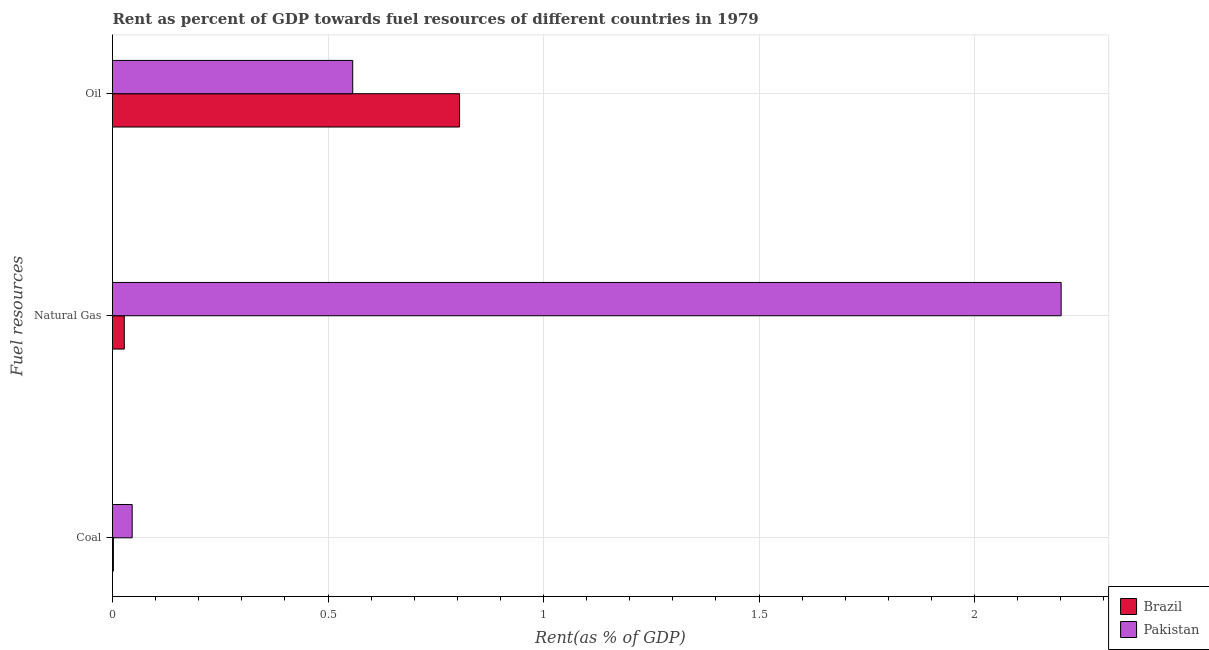How many groups of bars are there?
Ensure brevity in your answer.  3. Are the number of bars on each tick of the Y-axis equal?
Ensure brevity in your answer.  Yes. How many bars are there on the 1st tick from the top?
Offer a terse response. 2. How many bars are there on the 3rd tick from the bottom?
Give a very brief answer. 2. What is the label of the 3rd group of bars from the top?
Keep it short and to the point. Coal. What is the rent towards coal in Pakistan?
Your answer should be very brief. 0.05. Across all countries, what is the maximum rent towards natural gas?
Your answer should be very brief. 2.2. Across all countries, what is the minimum rent towards natural gas?
Make the answer very short. 0.03. What is the total rent towards coal in the graph?
Offer a very short reply. 0.05. What is the difference between the rent towards oil in Pakistan and that in Brazil?
Make the answer very short. -0.25. What is the difference between the rent towards natural gas in Brazil and the rent towards oil in Pakistan?
Your answer should be very brief. -0.53. What is the average rent towards coal per country?
Ensure brevity in your answer.  0.02. What is the difference between the rent towards coal and rent towards oil in Brazil?
Provide a succinct answer. -0.8. What is the ratio of the rent towards natural gas in Pakistan to that in Brazil?
Offer a terse response. 80.52. What is the difference between the highest and the second highest rent towards natural gas?
Provide a succinct answer. 2.17. What is the difference between the highest and the lowest rent towards natural gas?
Provide a succinct answer. 2.17. In how many countries, is the rent towards natural gas greater than the average rent towards natural gas taken over all countries?
Your response must be concise. 1. What does the 1st bar from the bottom in Coal represents?
Provide a short and direct response. Brazil. How many bars are there?
Offer a very short reply. 6. Are all the bars in the graph horizontal?
Make the answer very short. Yes. How are the legend labels stacked?
Offer a very short reply. Vertical. What is the title of the graph?
Ensure brevity in your answer.  Rent as percent of GDP towards fuel resources of different countries in 1979. Does "Niger" appear as one of the legend labels in the graph?
Your answer should be compact. No. What is the label or title of the X-axis?
Your answer should be very brief. Rent(as % of GDP). What is the label or title of the Y-axis?
Offer a terse response. Fuel resources. What is the Rent(as % of GDP) of Brazil in Coal?
Provide a short and direct response. 0. What is the Rent(as % of GDP) in Pakistan in Coal?
Your response must be concise. 0.05. What is the Rent(as % of GDP) of Brazil in Natural Gas?
Offer a terse response. 0.03. What is the Rent(as % of GDP) in Pakistan in Natural Gas?
Provide a short and direct response. 2.2. What is the Rent(as % of GDP) of Brazil in Oil?
Provide a short and direct response. 0.81. What is the Rent(as % of GDP) of Pakistan in Oil?
Keep it short and to the point. 0.56. Across all Fuel resources, what is the maximum Rent(as % of GDP) of Brazil?
Your answer should be very brief. 0.81. Across all Fuel resources, what is the maximum Rent(as % of GDP) of Pakistan?
Make the answer very short. 2.2. Across all Fuel resources, what is the minimum Rent(as % of GDP) in Brazil?
Provide a short and direct response. 0. Across all Fuel resources, what is the minimum Rent(as % of GDP) of Pakistan?
Your answer should be very brief. 0.05. What is the total Rent(as % of GDP) of Brazil in the graph?
Make the answer very short. 0.83. What is the total Rent(as % of GDP) in Pakistan in the graph?
Provide a succinct answer. 2.8. What is the difference between the Rent(as % of GDP) in Brazil in Coal and that in Natural Gas?
Offer a terse response. -0.03. What is the difference between the Rent(as % of GDP) of Pakistan in Coal and that in Natural Gas?
Your answer should be very brief. -2.16. What is the difference between the Rent(as % of GDP) in Brazil in Coal and that in Oil?
Provide a succinct answer. -0.8. What is the difference between the Rent(as % of GDP) of Pakistan in Coal and that in Oil?
Keep it short and to the point. -0.51. What is the difference between the Rent(as % of GDP) in Brazil in Natural Gas and that in Oil?
Offer a terse response. -0.78. What is the difference between the Rent(as % of GDP) in Pakistan in Natural Gas and that in Oil?
Ensure brevity in your answer.  1.64. What is the difference between the Rent(as % of GDP) in Brazil in Coal and the Rent(as % of GDP) in Pakistan in Natural Gas?
Your answer should be very brief. -2.2. What is the difference between the Rent(as % of GDP) of Brazil in Coal and the Rent(as % of GDP) of Pakistan in Oil?
Keep it short and to the point. -0.56. What is the difference between the Rent(as % of GDP) in Brazil in Natural Gas and the Rent(as % of GDP) in Pakistan in Oil?
Provide a succinct answer. -0.53. What is the average Rent(as % of GDP) in Brazil per Fuel resources?
Provide a short and direct response. 0.28. What is the average Rent(as % of GDP) in Pakistan per Fuel resources?
Offer a terse response. 0.93. What is the difference between the Rent(as % of GDP) of Brazil and Rent(as % of GDP) of Pakistan in Coal?
Provide a succinct answer. -0.04. What is the difference between the Rent(as % of GDP) of Brazil and Rent(as % of GDP) of Pakistan in Natural Gas?
Your answer should be compact. -2.17. What is the difference between the Rent(as % of GDP) of Brazil and Rent(as % of GDP) of Pakistan in Oil?
Offer a very short reply. 0.25. What is the ratio of the Rent(as % of GDP) in Brazil in Coal to that in Natural Gas?
Provide a short and direct response. 0.07. What is the ratio of the Rent(as % of GDP) in Pakistan in Coal to that in Natural Gas?
Give a very brief answer. 0.02. What is the ratio of the Rent(as % of GDP) in Brazil in Coal to that in Oil?
Offer a very short reply. 0. What is the ratio of the Rent(as % of GDP) of Pakistan in Coal to that in Oil?
Ensure brevity in your answer.  0.08. What is the ratio of the Rent(as % of GDP) in Brazil in Natural Gas to that in Oil?
Offer a very short reply. 0.03. What is the ratio of the Rent(as % of GDP) in Pakistan in Natural Gas to that in Oil?
Make the answer very short. 3.95. What is the difference between the highest and the second highest Rent(as % of GDP) in Pakistan?
Your answer should be compact. 1.64. What is the difference between the highest and the lowest Rent(as % of GDP) in Brazil?
Ensure brevity in your answer.  0.8. What is the difference between the highest and the lowest Rent(as % of GDP) in Pakistan?
Ensure brevity in your answer.  2.16. 